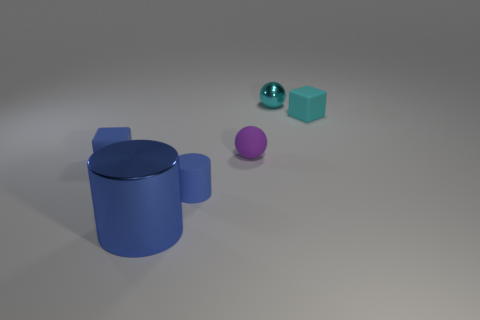What number of shiny objects are big yellow cylinders or purple balls?
Ensure brevity in your answer.  0. Is the number of rubber cylinders less than the number of small blocks?
Give a very brief answer. Yes. There is a cyan rubber thing; is it the same size as the matte object that is in front of the blue block?
Your answer should be compact. Yes. The cyan rubber thing is what size?
Make the answer very short. Small. Are there fewer blue shiny objects that are behind the matte cylinder than purple matte spheres?
Offer a very short reply. Yes. Do the matte cylinder and the blue metal object have the same size?
Your response must be concise. No. Is there any other thing that has the same size as the blue metal cylinder?
Your answer should be very brief. No. There is a sphere that is made of the same material as the small blue cylinder; what is its color?
Make the answer very short. Purple. Are there fewer blue metallic things that are to the right of the tiny cyan shiny object than matte objects that are behind the tiny blue block?
Provide a short and direct response. Yes. How many matte balls have the same color as the small shiny sphere?
Offer a terse response. 0. 